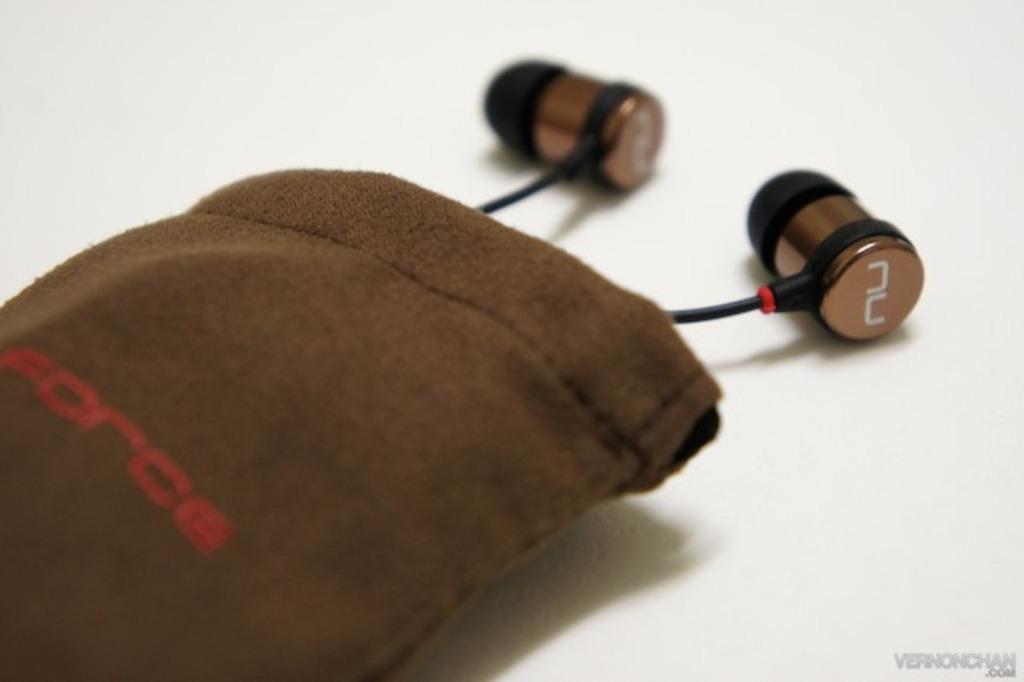In one or two sentences, can you explain what this image depicts? In the image in the center, we can see one pouch, which is in brown color and we can see something written on it. And we can see earphones in the pouch. 